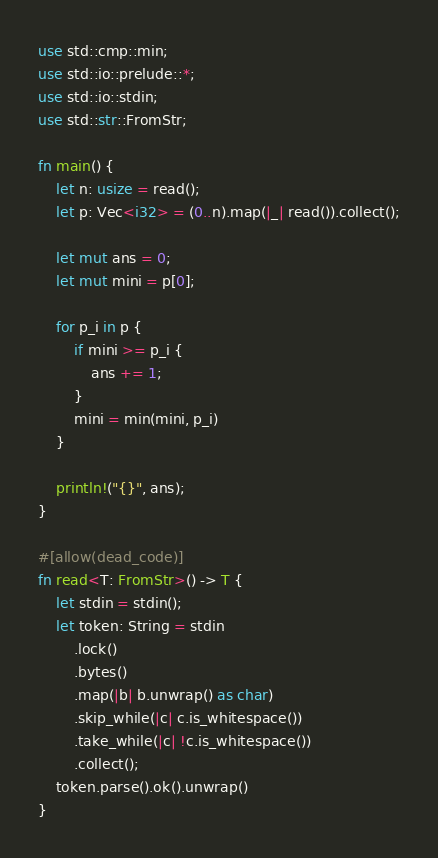Convert code to text. <code><loc_0><loc_0><loc_500><loc_500><_Rust_>use std::cmp::min;
use std::io::prelude::*;
use std::io::stdin;
use std::str::FromStr;

fn main() {
    let n: usize = read();
    let p: Vec<i32> = (0..n).map(|_| read()).collect();

    let mut ans = 0;
    let mut mini = p[0];

    for p_i in p {
        if mini >= p_i {
            ans += 1;
        }
        mini = min(mini, p_i)
    }

    println!("{}", ans);
}

#[allow(dead_code)]
fn read<T: FromStr>() -> T {
    let stdin = stdin();
    let token: String = stdin
        .lock()
        .bytes()
        .map(|b| b.unwrap() as char)
        .skip_while(|c| c.is_whitespace())
        .take_while(|c| !c.is_whitespace())
        .collect();
    token.parse().ok().unwrap()
}
</code> 